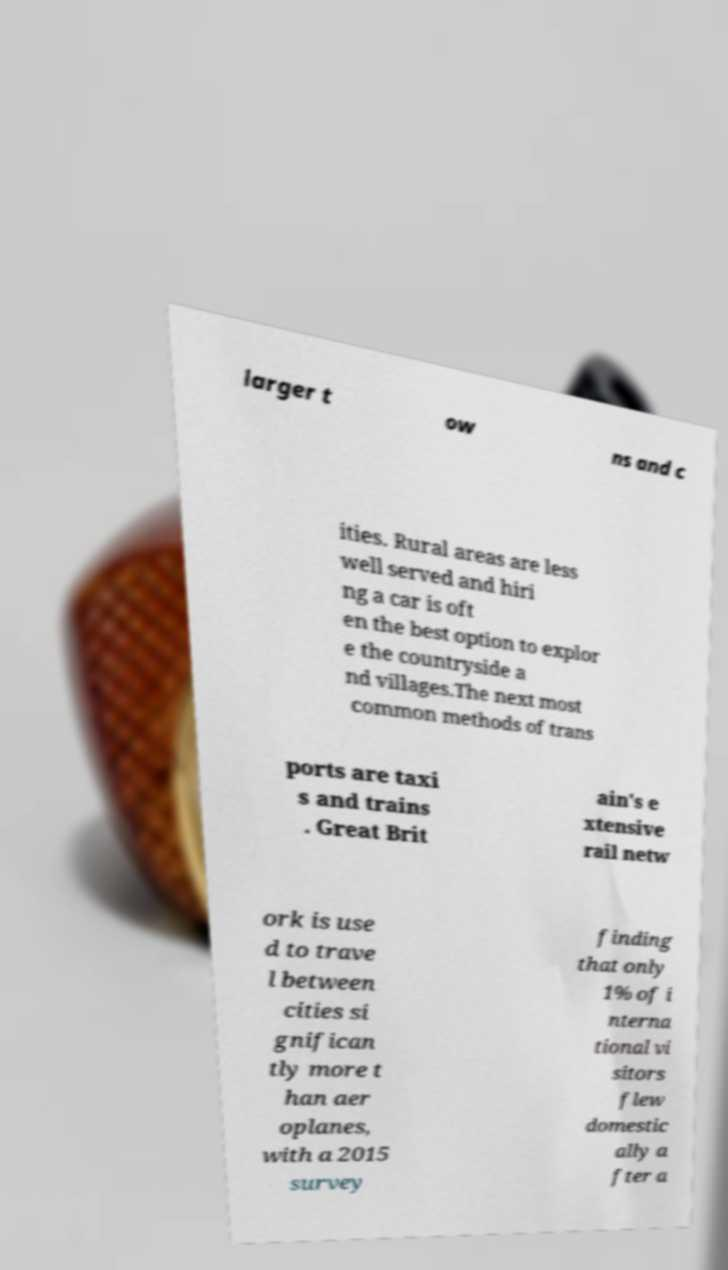Could you assist in decoding the text presented in this image and type it out clearly? larger t ow ns and c ities. Rural areas are less well served and hiri ng a car is oft en the best option to explor e the countryside a nd villages.The next most common methods of trans ports are taxi s and trains . Great Brit ain's e xtensive rail netw ork is use d to trave l between cities si gnifican tly more t han aer oplanes, with a 2015 survey finding that only 1% of i nterna tional vi sitors flew domestic ally a fter a 